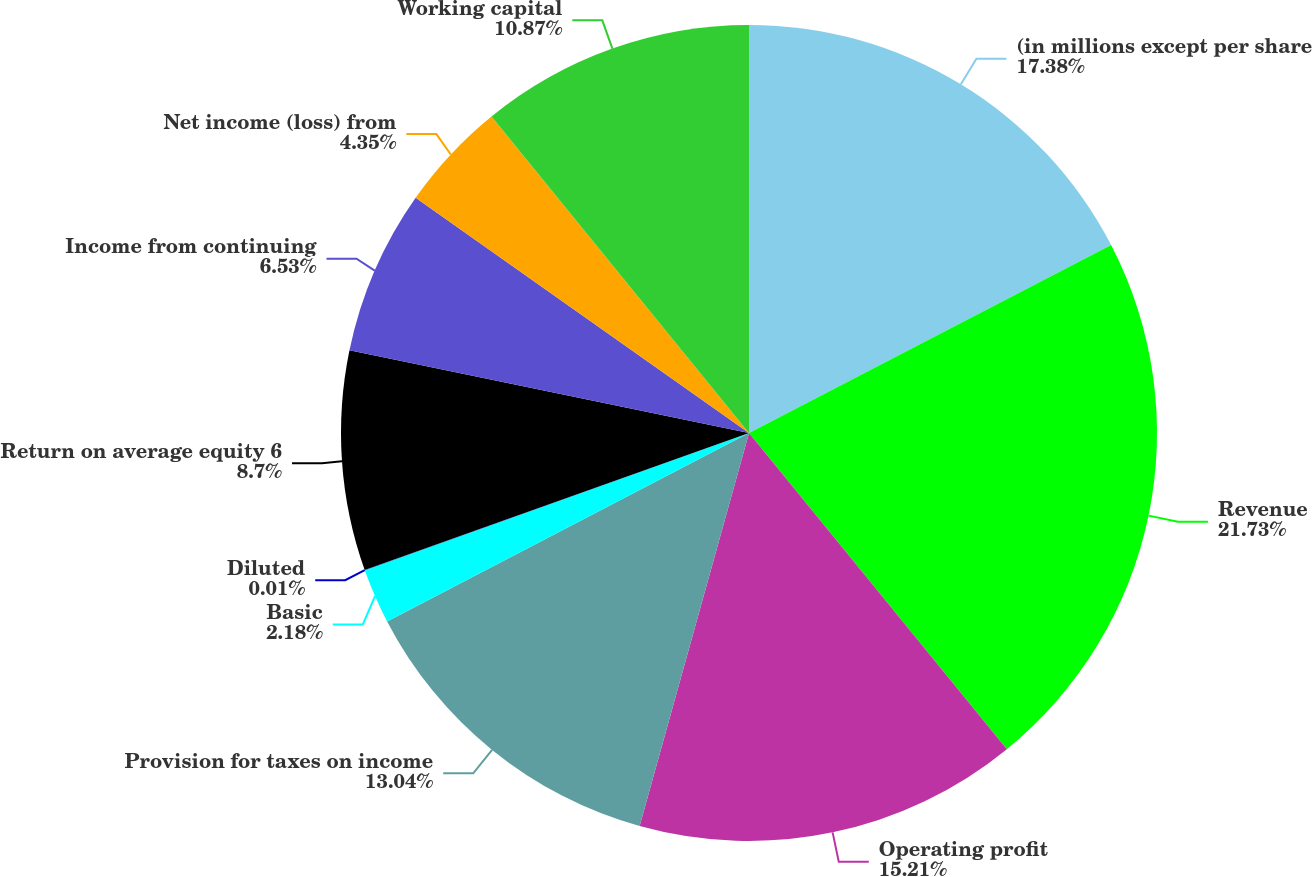Convert chart. <chart><loc_0><loc_0><loc_500><loc_500><pie_chart><fcel>(in millions except per share<fcel>Revenue<fcel>Operating profit<fcel>Provision for taxes on income<fcel>Basic<fcel>Diluted<fcel>Return on average equity 6<fcel>Income from continuing<fcel>Net income (loss) from<fcel>Working capital<nl><fcel>17.38%<fcel>21.73%<fcel>15.21%<fcel>13.04%<fcel>2.18%<fcel>0.01%<fcel>8.7%<fcel>6.53%<fcel>4.35%<fcel>10.87%<nl></chart> 